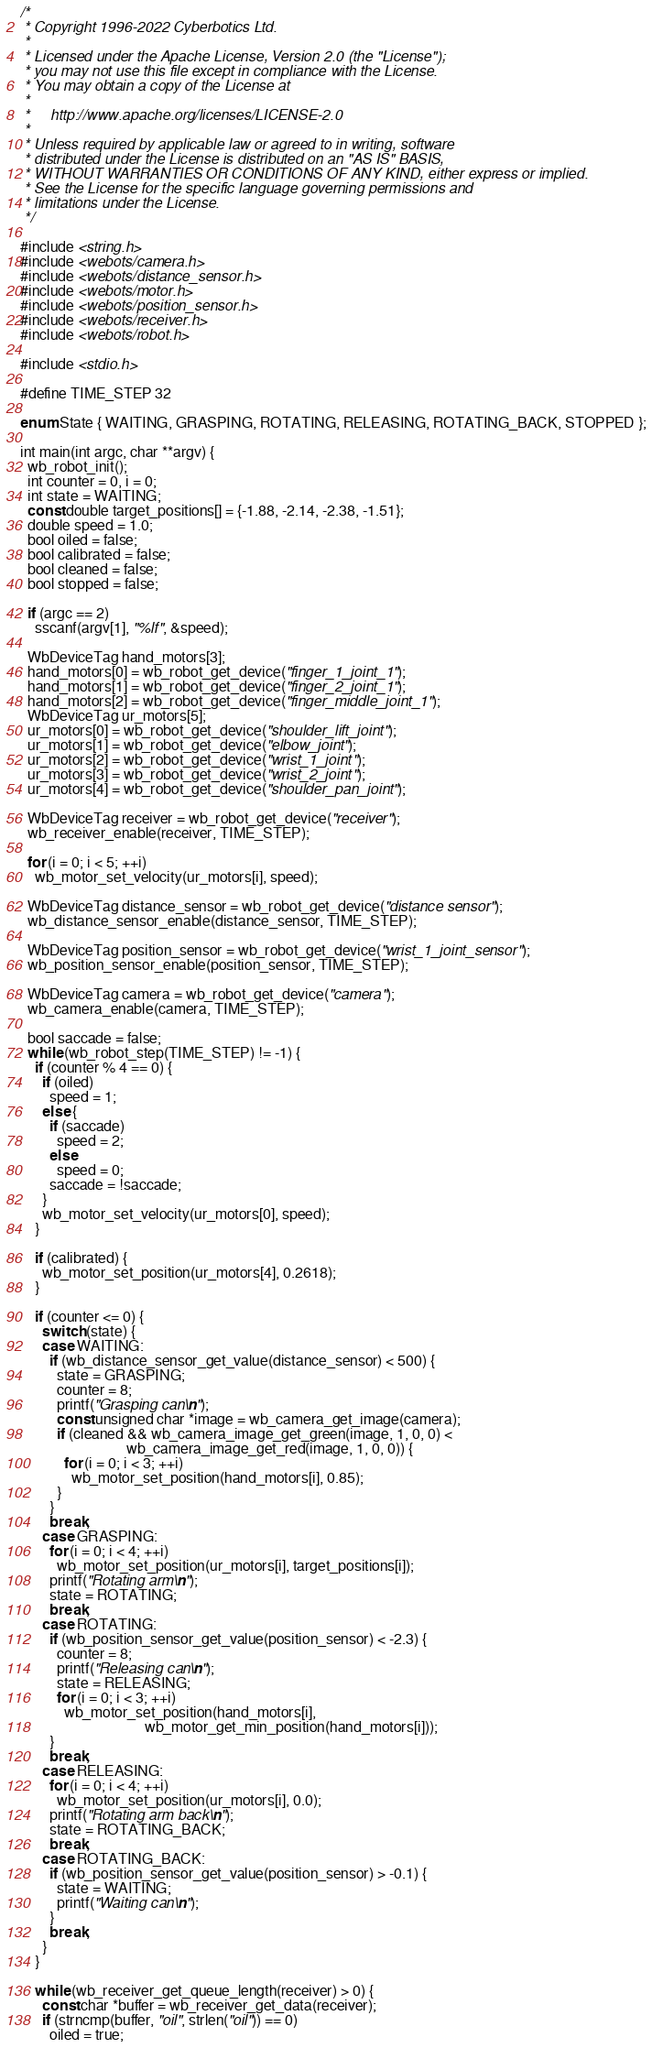Convert code to text. <code><loc_0><loc_0><loc_500><loc_500><_C_>/*
 * Copyright 1996-2022 Cyberbotics Ltd.
 *
 * Licensed under the Apache License, Version 2.0 (the "License");
 * you may not use this file except in compliance with the License.
 * You may obtain a copy of the License at
 *
 *     http://www.apache.org/licenses/LICENSE-2.0
 *
 * Unless required by applicable law or agreed to in writing, software
 * distributed under the License is distributed on an "AS IS" BASIS,
 * WITHOUT WARRANTIES OR CONDITIONS OF ANY KIND, either express or implied.
 * See the License for the specific language governing permissions and
 * limitations under the License.
 */

#include <string.h>
#include <webots/camera.h>
#include <webots/distance_sensor.h>
#include <webots/motor.h>
#include <webots/position_sensor.h>
#include <webots/receiver.h>
#include <webots/robot.h>

#include <stdio.h>

#define TIME_STEP 32

enum State { WAITING, GRASPING, ROTATING, RELEASING, ROTATING_BACK, STOPPED };

int main(int argc, char **argv) {
  wb_robot_init();
  int counter = 0, i = 0;
  int state = WAITING;
  const double target_positions[] = {-1.88, -2.14, -2.38, -1.51};
  double speed = 1.0;
  bool oiled = false;
  bool calibrated = false;
  bool cleaned = false;
  bool stopped = false;

  if (argc == 2)
    sscanf(argv[1], "%lf", &speed);

  WbDeviceTag hand_motors[3];
  hand_motors[0] = wb_robot_get_device("finger_1_joint_1");
  hand_motors[1] = wb_robot_get_device("finger_2_joint_1");
  hand_motors[2] = wb_robot_get_device("finger_middle_joint_1");
  WbDeviceTag ur_motors[5];
  ur_motors[0] = wb_robot_get_device("shoulder_lift_joint");
  ur_motors[1] = wb_robot_get_device("elbow_joint");
  ur_motors[2] = wb_robot_get_device("wrist_1_joint");
  ur_motors[3] = wb_robot_get_device("wrist_2_joint");
  ur_motors[4] = wb_robot_get_device("shoulder_pan_joint");

  WbDeviceTag receiver = wb_robot_get_device("receiver");
  wb_receiver_enable(receiver, TIME_STEP);

  for (i = 0; i < 5; ++i)
    wb_motor_set_velocity(ur_motors[i], speed);

  WbDeviceTag distance_sensor = wb_robot_get_device("distance sensor");
  wb_distance_sensor_enable(distance_sensor, TIME_STEP);

  WbDeviceTag position_sensor = wb_robot_get_device("wrist_1_joint_sensor");
  wb_position_sensor_enable(position_sensor, TIME_STEP);

  WbDeviceTag camera = wb_robot_get_device("camera");
  wb_camera_enable(camera, TIME_STEP);

  bool saccade = false;
  while (wb_robot_step(TIME_STEP) != -1) {
    if (counter % 4 == 0) {
      if (oiled)
        speed = 1;
      else {
        if (saccade)
          speed = 2;
        else
          speed = 0;
        saccade = !saccade;
      }
      wb_motor_set_velocity(ur_motors[0], speed);
    }

    if (calibrated) {
      wb_motor_set_position(ur_motors[4], 0.2618);
    }

    if (counter <= 0) {
      switch (state) {
      case WAITING:
        if (wb_distance_sensor_get_value(distance_sensor) < 500) {
          state = GRASPING;
          counter = 8;
          printf("Grasping can\n");
          const unsigned char *image = wb_camera_get_image(camera);
          if (cleaned && wb_camera_image_get_green(image, 1, 0, 0) <
                             wb_camera_image_get_red(image, 1, 0, 0)) {
            for (i = 0; i < 3; ++i)
              wb_motor_set_position(hand_motors[i], 0.85);
          }
        }
        break;
      case GRASPING:
        for (i = 0; i < 4; ++i)
          wb_motor_set_position(ur_motors[i], target_positions[i]);
        printf("Rotating arm\n");
        state = ROTATING;
        break;
      case ROTATING:
        if (wb_position_sensor_get_value(position_sensor) < -2.3) {
          counter = 8;
          printf("Releasing can\n");
          state = RELEASING;
          for (i = 0; i < 3; ++i)
            wb_motor_set_position(hand_motors[i],
                                  wb_motor_get_min_position(hand_motors[i]));
        }
        break;
      case RELEASING:
        for (i = 0; i < 4; ++i)
          wb_motor_set_position(ur_motors[i], 0.0);
        printf("Rotating arm back\n");
        state = ROTATING_BACK;
        break;
      case ROTATING_BACK:
        if (wb_position_sensor_get_value(position_sensor) > -0.1) {
          state = WAITING;
          printf("Waiting can\n");
        }
        break;
      }
    }

    while (wb_receiver_get_queue_length(receiver) > 0) {
      const char *buffer = wb_receiver_get_data(receiver);
      if (strncmp(buffer, "oil", strlen("oil")) == 0)
        oiled = true;</code> 